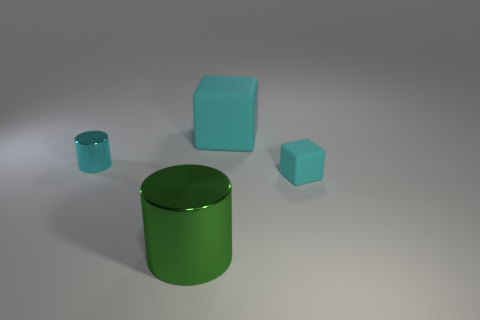The tiny metal thing is what color?
Give a very brief answer. Cyan. What is the size of the shiny cylinder to the right of the cyan metal object left of the big object that is on the left side of the large cyan matte block?
Your answer should be compact. Large. What number of other things are there of the same shape as the large cyan thing?
Your response must be concise. 1. What color is the object that is both on the left side of the big matte block and to the right of the small cylinder?
Give a very brief answer. Green. Does the tiny shiny object behind the green thing have the same color as the large cube?
Give a very brief answer. Yes. What number of cubes are either large green things or cyan matte objects?
Offer a terse response. 2. The cyan rubber thing that is right of the large cyan rubber thing has what shape?
Your answer should be very brief. Cube. There is a small object that is in front of the shiny thing behind the small thing that is on the right side of the green cylinder; what color is it?
Your answer should be compact. Cyan. Is the material of the big cylinder the same as the tiny cyan cylinder?
Your response must be concise. Yes. How many brown objects are large blocks or cylinders?
Your response must be concise. 0. 